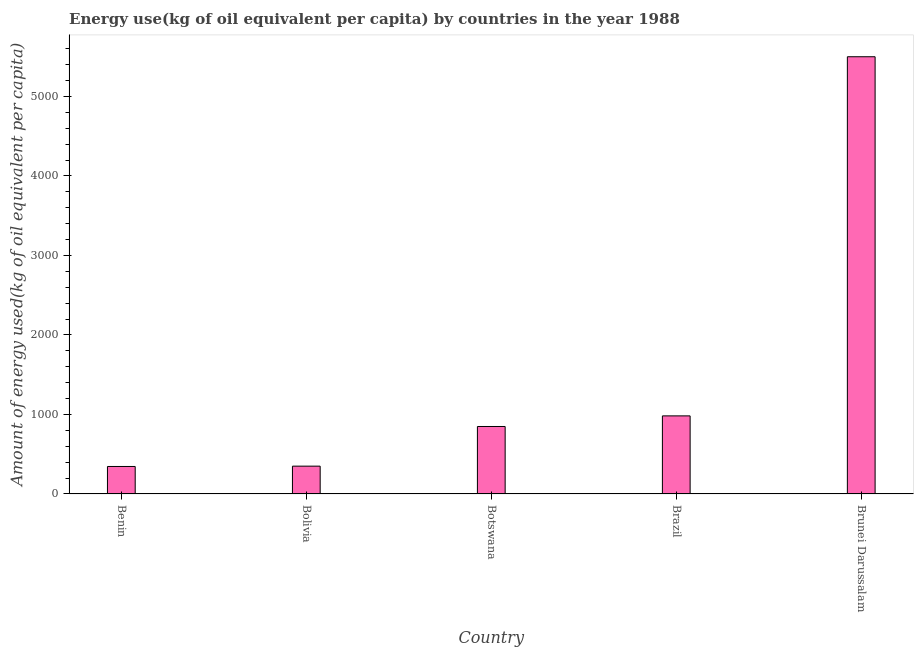What is the title of the graph?
Your answer should be compact. Energy use(kg of oil equivalent per capita) by countries in the year 1988. What is the label or title of the Y-axis?
Give a very brief answer. Amount of energy used(kg of oil equivalent per capita). What is the amount of energy used in Brazil?
Offer a very short reply. 982.2. Across all countries, what is the maximum amount of energy used?
Your response must be concise. 5499.11. Across all countries, what is the minimum amount of energy used?
Provide a short and direct response. 345.7. In which country was the amount of energy used maximum?
Offer a terse response. Brunei Darussalam. In which country was the amount of energy used minimum?
Your response must be concise. Benin. What is the sum of the amount of energy used?
Provide a succinct answer. 8025.57. What is the difference between the amount of energy used in Benin and Brunei Darussalam?
Make the answer very short. -5153.42. What is the average amount of energy used per country?
Your answer should be compact. 1605.11. What is the median amount of energy used?
Provide a succinct answer. 848.66. What is the ratio of the amount of energy used in Bolivia to that in Brunei Darussalam?
Make the answer very short. 0.06. What is the difference between the highest and the second highest amount of energy used?
Provide a succinct answer. 4516.92. Is the sum of the amount of energy used in Brazil and Brunei Darussalam greater than the maximum amount of energy used across all countries?
Offer a very short reply. Yes. What is the difference between the highest and the lowest amount of energy used?
Make the answer very short. 5153.42. How many bars are there?
Keep it short and to the point. 5. Are all the bars in the graph horizontal?
Make the answer very short. No. What is the Amount of energy used(kg of oil equivalent per capita) of Benin?
Offer a very short reply. 345.7. What is the Amount of energy used(kg of oil equivalent per capita) in Bolivia?
Provide a short and direct response. 349.91. What is the Amount of energy used(kg of oil equivalent per capita) of Botswana?
Offer a very short reply. 848.66. What is the Amount of energy used(kg of oil equivalent per capita) in Brazil?
Keep it short and to the point. 982.2. What is the Amount of energy used(kg of oil equivalent per capita) in Brunei Darussalam?
Make the answer very short. 5499.11. What is the difference between the Amount of energy used(kg of oil equivalent per capita) in Benin and Bolivia?
Your answer should be very brief. -4.21. What is the difference between the Amount of energy used(kg of oil equivalent per capita) in Benin and Botswana?
Your response must be concise. -502.96. What is the difference between the Amount of energy used(kg of oil equivalent per capita) in Benin and Brazil?
Your answer should be compact. -636.5. What is the difference between the Amount of energy used(kg of oil equivalent per capita) in Benin and Brunei Darussalam?
Your answer should be very brief. -5153.42. What is the difference between the Amount of energy used(kg of oil equivalent per capita) in Bolivia and Botswana?
Provide a short and direct response. -498.75. What is the difference between the Amount of energy used(kg of oil equivalent per capita) in Bolivia and Brazil?
Offer a terse response. -632.29. What is the difference between the Amount of energy used(kg of oil equivalent per capita) in Bolivia and Brunei Darussalam?
Your response must be concise. -5149.21. What is the difference between the Amount of energy used(kg of oil equivalent per capita) in Botswana and Brazil?
Ensure brevity in your answer.  -133.54. What is the difference between the Amount of energy used(kg of oil equivalent per capita) in Botswana and Brunei Darussalam?
Your answer should be very brief. -4650.46. What is the difference between the Amount of energy used(kg of oil equivalent per capita) in Brazil and Brunei Darussalam?
Offer a terse response. -4516.92. What is the ratio of the Amount of energy used(kg of oil equivalent per capita) in Benin to that in Botswana?
Offer a very short reply. 0.41. What is the ratio of the Amount of energy used(kg of oil equivalent per capita) in Benin to that in Brazil?
Your answer should be very brief. 0.35. What is the ratio of the Amount of energy used(kg of oil equivalent per capita) in Benin to that in Brunei Darussalam?
Give a very brief answer. 0.06. What is the ratio of the Amount of energy used(kg of oil equivalent per capita) in Bolivia to that in Botswana?
Ensure brevity in your answer.  0.41. What is the ratio of the Amount of energy used(kg of oil equivalent per capita) in Bolivia to that in Brazil?
Provide a short and direct response. 0.36. What is the ratio of the Amount of energy used(kg of oil equivalent per capita) in Bolivia to that in Brunei Darussalam?
Provide a short and direct response. 0.06. What is the ratio of the Amount of energy used(kg of oil equivalent per capita) in Botswana to that in Brazil?
Offer a terse response. 0.86. What is the ratio of the Amount of energy used(kg of oil equivalent per capita) in Botswana to that in Brunei Darussalam?
Offer a very short reply. 0.15. What is the ratio of the Amount of energy used(kg of oil equivalent per capita) in Brazil to that in Brunei Darussalam?
Provide a succinct answer. 0.18. 